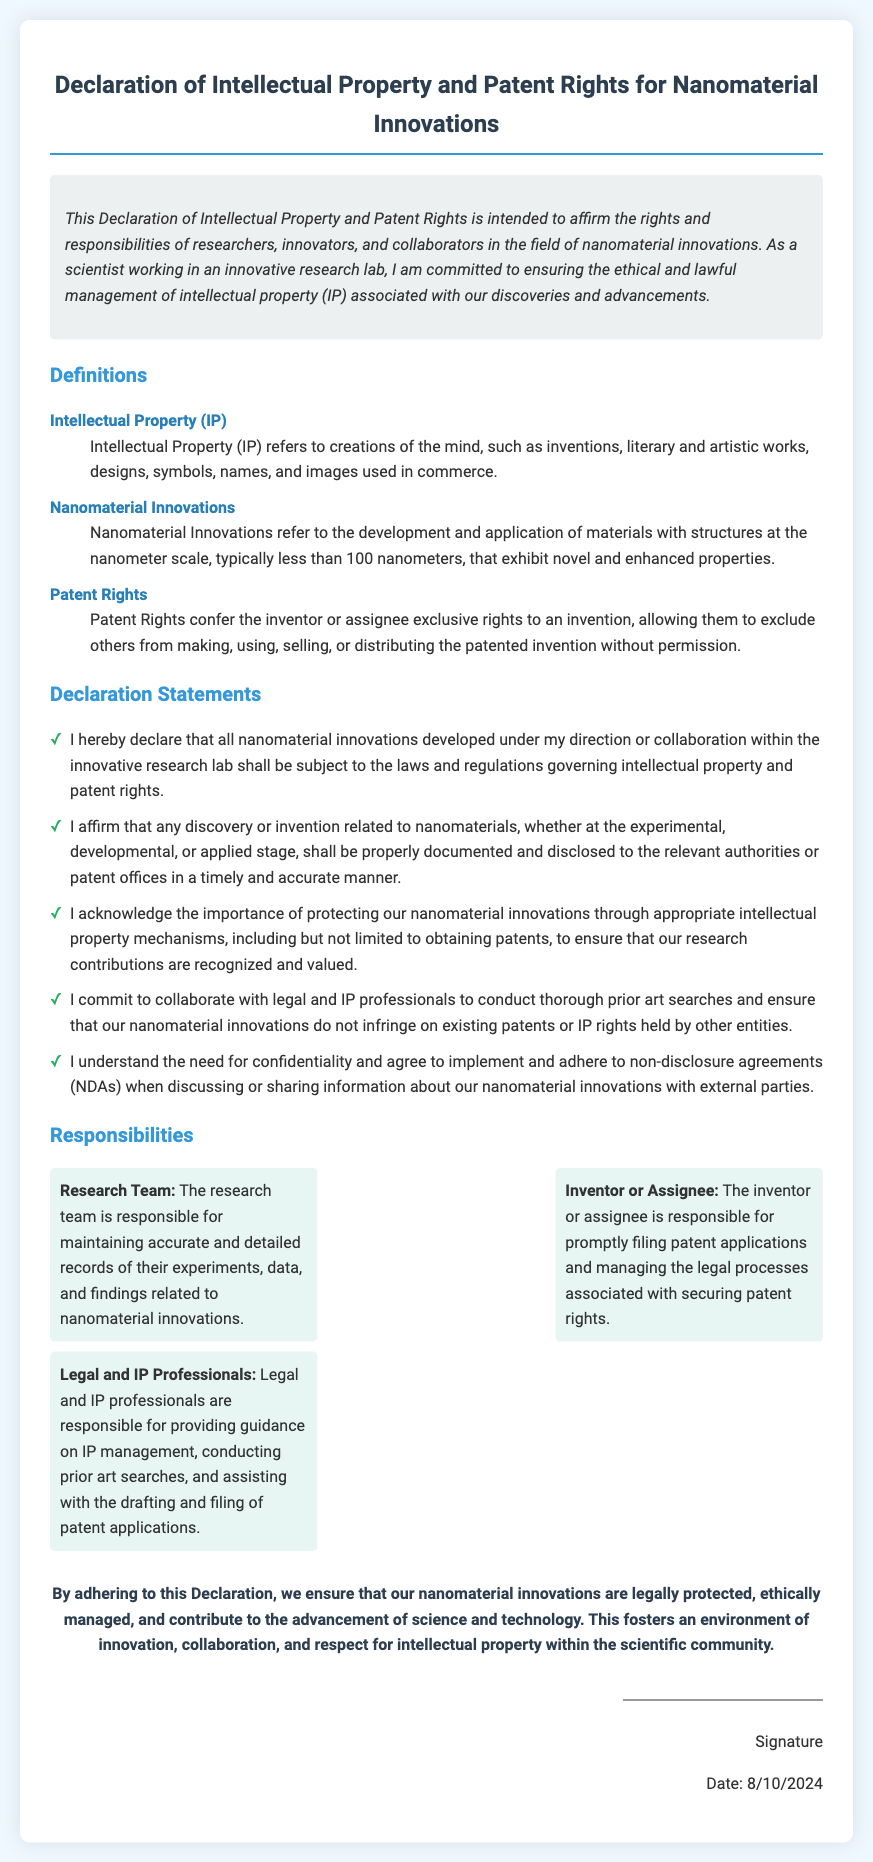What is the title of the document? The title of the document is presented prominently at the top and summarizes its purpose.
Answer: Declaration of Intellectual Property and Patent Rights for Nanomaterial Innovations What does IP stand for? IP is defined early in the document as one of the key terms essential to understanding the declaration.
Answer: Intellectual Property What is the maximum size for nanomaterials defined in the document? The document specifies a size limit for nanomaterials in its definitions section.
Answer: less than 100 nanometers Who is responsible for filing patent applications according to the document? The responsibilities section outlines specific roles, including who is tasked with patent application filings.
Answer: Inventor or Assignee What must researchers maintain according to their responsibilities? The responsibilities outline specific duties for the research team related to experimentation documentation.
Answer: accurate and detailed records What do legal and IP professionals assist with? The role of legal and IP professionals is described in the responsibilities section, outlining their support functions.
Answer: guidance on IP management What is the significance of this Declaration, as stated in the document? The significance section summarizes the broader impact of adhering to the declaration on innovation and ethics.
Answer: legally protected, ethically managed When is the current date displayed in the document? The document includes a script that auto-displays the current date upon rendering, referring to when it is signed.
Answer: Dynamic based on rendering date 